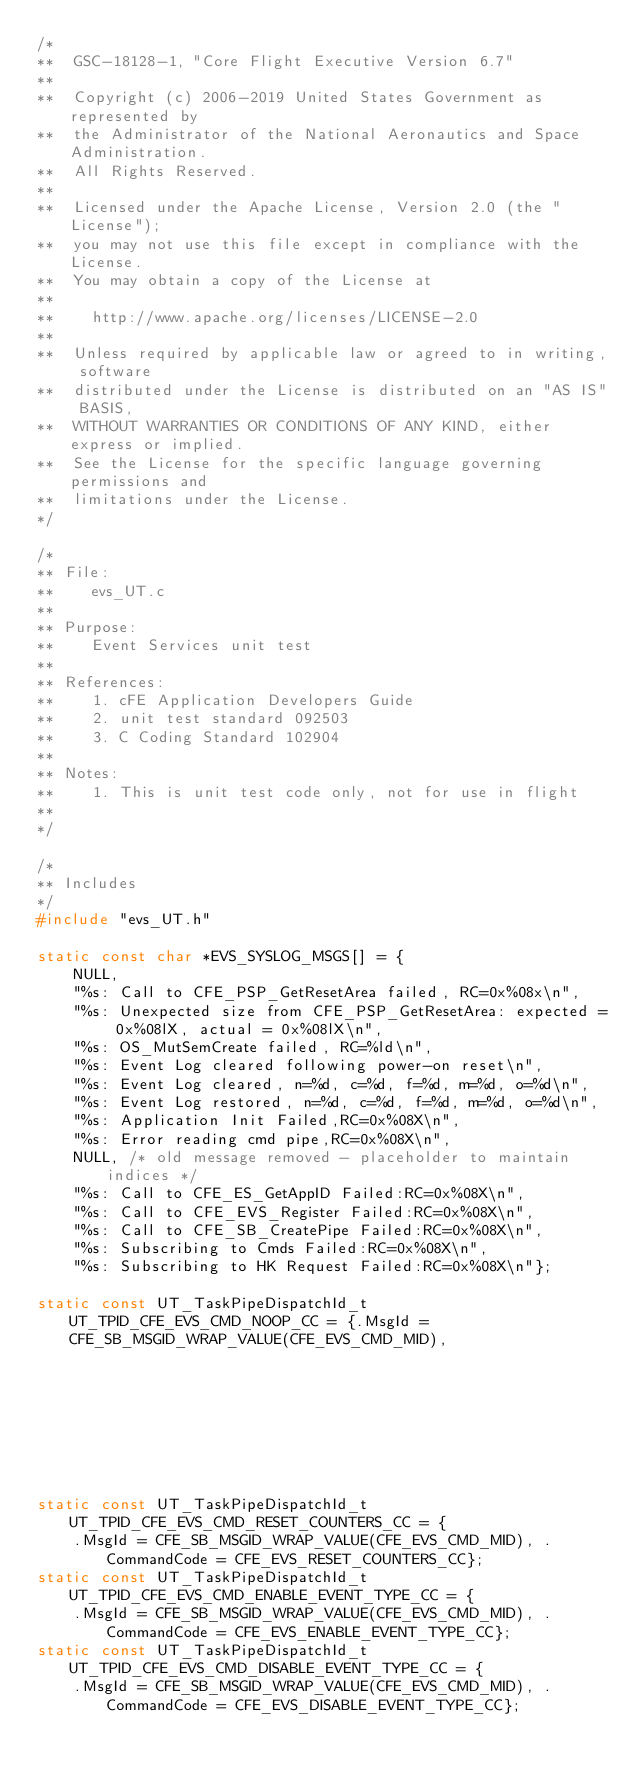Convert code to text. <code><loc_0><loc_0><loc_500><loc_500><_C_>/*
**  GSC-18128-1, "Core Flight Executive Version 6.7"
**
**  Copyright (c) 2006-2019 United States Government as represented by
**  the Administrator of the National Aeronautics and Space Administration.
**  All Rights Reserved.
**
**  Licensed under the Apache License, Version 2.0 (the "License");
**  you may not use this file except in compliance with the License.
**  You may obtain a copy of the License at
**
**    http://www.apache.org/licenses/LICENSE-2.0
**
**  Unless required by applicable law or agreed to in writing, software
**  distributed under the License is distributed on an "AS IS" BASIS,
**  WITHOUT WARRANTIES OR CONDITIONS OF ANY KIND, either express or implied.
**  See the License for the specific language governing permissions and
**  limitations under the License.
*/

/*
** File:
**    evs_UT.c
**
** Purpose:
**    Event Services unit test
**
** References:
**    1. cFE Application Developers Guide
**    2. unit test standard 092503
**    3. C Coding Standard 102904
**
** Notes:
**    1. This is unit test code only, not for use in flight
**
*/

/*
** Includes
*/
#include "evs_UT.h"

static const char *EVS_SYSLOG_MSGS[] = {
    NULL,
    "%s: Call to CFE_PSP_GetResetArea failed, RC=0x%08x\n",
    "%s: Unexpected size from CFE_PSP_GetResetArea: expected = 0x%08lX, actual = 0x%08lX\n",
    "%s: OS_MutSemCreate failed, RC=%ld\n",
    "%s: Event Log cleared following power-on reset\n",
    "%s: Event Log cleared, n=%d, c=%d, f=%d, m=%d, o=%d\n",
    "%s: Event Log restored, n=%d, c=%d, f=%d, m=%d, o=%d\n",
    "%s: Application Init Failed,RC=0x%08X\n",
    "%s: Error reading cmd pipe,RC=0x%08X\n",
    NULL, /* old message removed - placeholder to maintain indices */
    "%s: Call to CFE_ES_GetAppID Failed:RC=0x%08X\n",
    "%s: Call to CFE_EVS_Register Failed:RC=0x%08X\n",
    "%s: Call to CFE_SB_CreatePipe Failed:RC=0x%08X\n",
    "%s: Subscribing to Cmds Failed:RC=0x%08X\n",
    "%s: Subscribing to HK Request Failed:RC=0x%08X\n"};

static const UT_TaskPipeDispatchId_t UT_TPID_CFE_EVS_CMD_NOOP_CC = {.MsgId = CFE_SB_MSGID_WRAP_VALUE(CFE_EVS_CMD_MID),
                                                                    .CommandCode = CFE_EVS_NOOP_CC};
static const UT_TaskPipeDispatchId_t UT_TPID_CFE_EVS_CMD_RESET_COUNTERS_CC = {
    .MsgId = CFE_SB_MSGID_WRAP_VALUE(CFE_EVS_CMD_MID), .CommandCode = CFE_EVS_RESET_COUNTERS_CC};
static const UT_TaskPipeDispatchId_t UT_TPID_CFE_EVS_CMD_ENABLE_EVENT_TYPE_CC = {
    .MsgId = CFE_SB_MSGID_WRAP_VALUE(CFE_EVS_CMD_MID), .CommandCode = CFE_EVS_ENABLE_EVENT_TYPE_CC};
static const UT_TaskPipeDispatchId_t UT_TPID_CFE_EVS_CMD_DISABLE_EVENT_TYPE_CC = {
    .MsgId = CFE_SB_MSGID_WRAP_VALUE(CFE_EVS_CMD_MID), .CommandCode = CFE_EVS_DISABLE_EVENT_TYPE_CC};</code> 